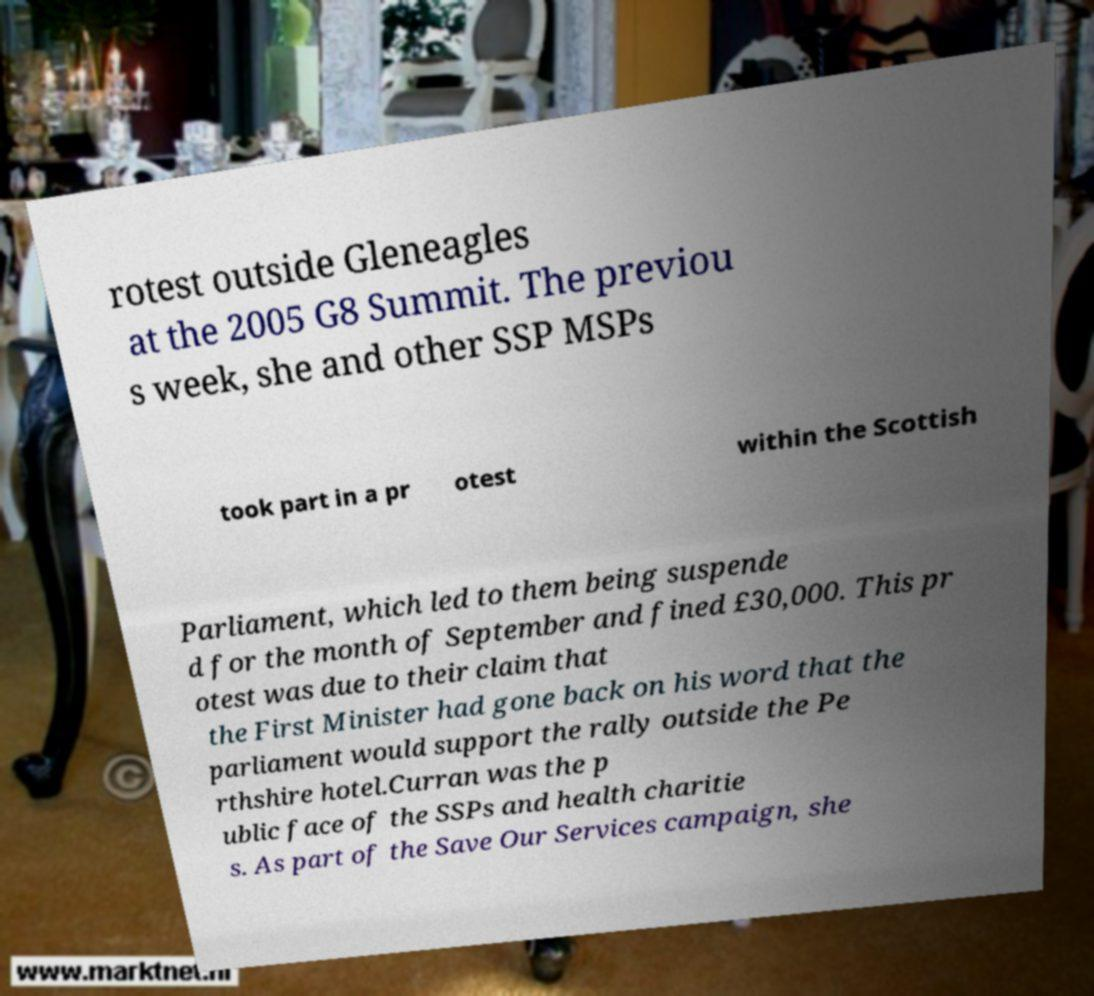What messages or text are displayed in this image? I need them in a readable, typed format. rotest outside Gleneagles at the 2005 G8 Summit. The previou s week, she and other SSP MSPs took part in a pr otest within the Scottish Parliament, which led to them being suspende d for the month of September and fined £30,000. This pr otest was due to their claim that the First Minister had gone back on his word that the parliament would support the rally outside the Pe rthshire hotel.Curran was the p ublic face of the SSPs and health charitie s. As part of the Save Our Services campaign, she 